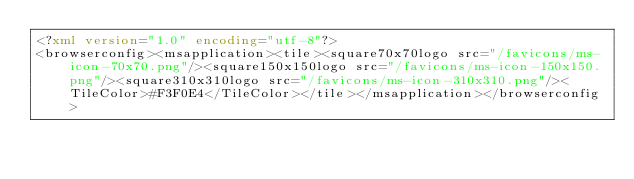Convert code to text. <code><loc_0><loc_0><loc_500><loc_500><_XML_><?xml version="1.0" encoding="utf-8"?>
<browserconfig><msapplication><tile><square70x70logo src="/favicons/ms-icon-70x70.png"/><square150x150logo src="/favicons/ms-icon-150x150.png"/><square310x310logo src="/favicons/ms-icon-310x310.png"/><TileColor>#F3F0E4</TileColor></tile></msapplication></browserconfig></code> 